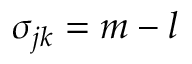Convert formula to latex. <formula><loc_0><loc_0><loc_500><loc_500>\sigma _ { j k } = m - l</formula> 